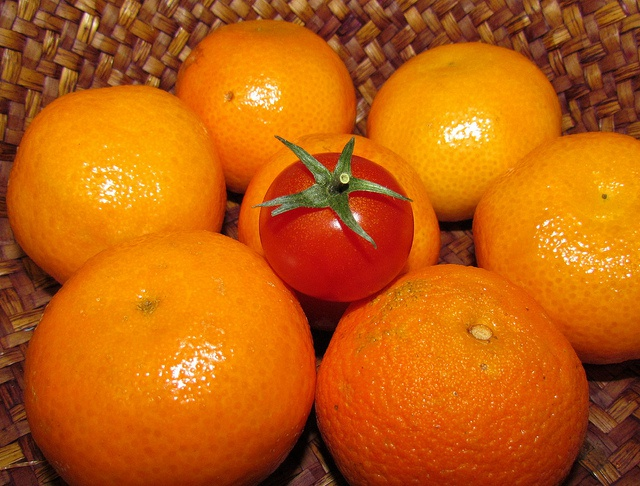Describe the objects in this image and their specific colors. I can see orange in maroon, orange, red, and brown tones, orange in maroon, red, brown, and orange tones, and orange in maroon, orange, red, and brown tones in this image. 